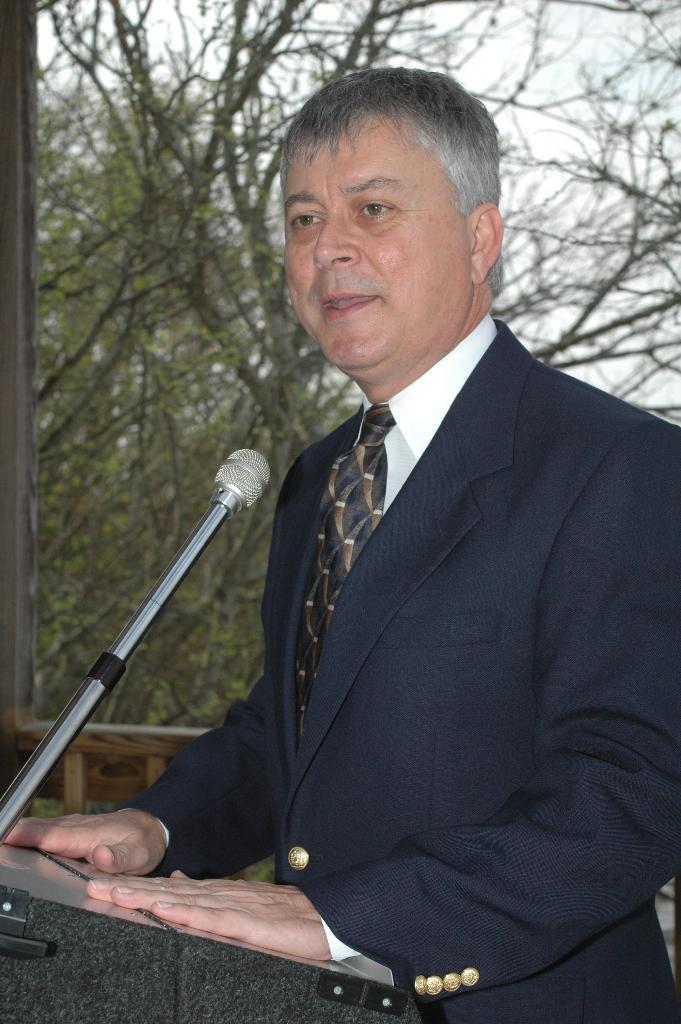How would you summarize this image in a sentence or two? In this image we can see a person standing in front of the podium, on the podium, we can see a mic, there are some trees and also we can see the sky. 